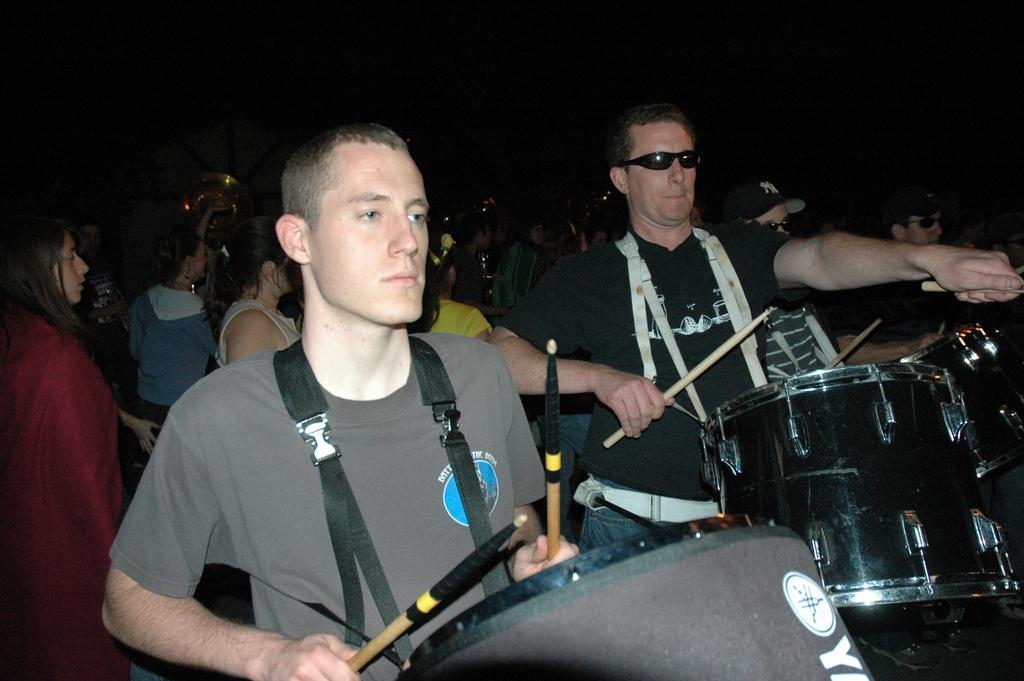Describe this image in one or two sentences. In this picture we can see two people holding the drums and playing them and behind them there are some other people. 